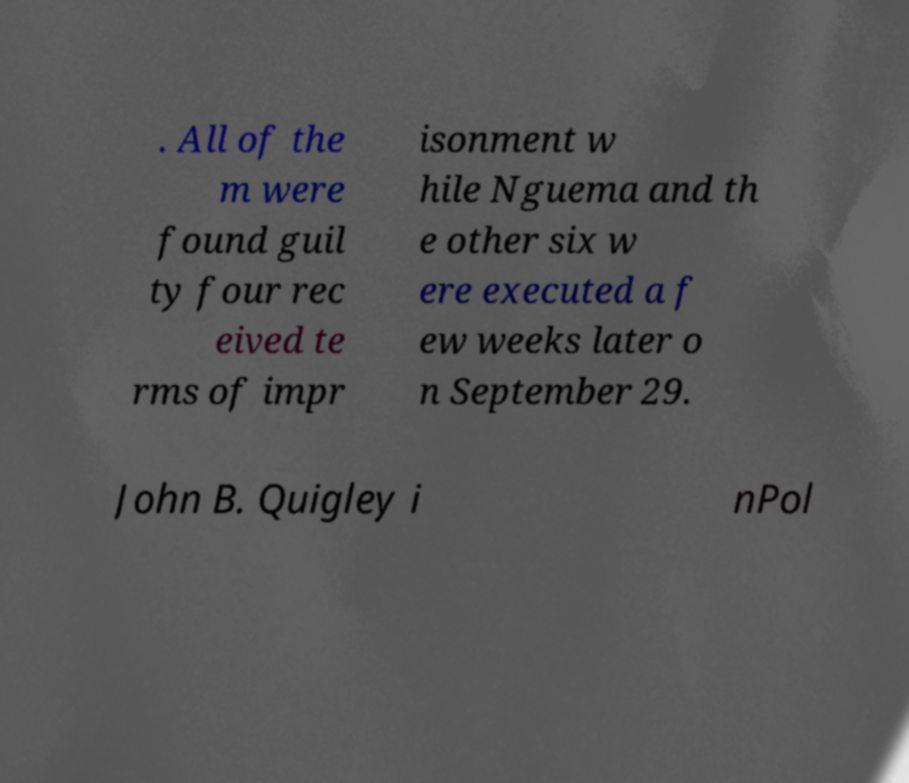I need the written content from this picture converted into text. Can you do that? . All of the m were found guil ty four rec eived te rms of impr isonment w hile Nguema and th e other six w ere executed a f ew weeks later o n September 29. John B. Quigley i nPol 